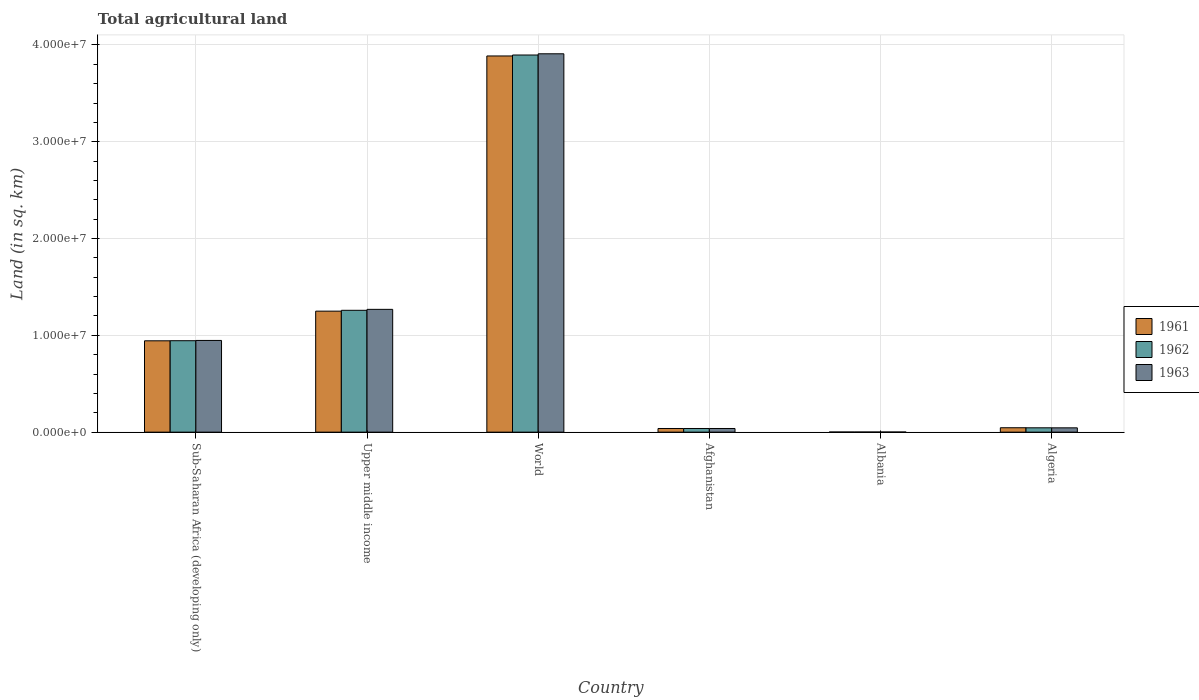How many different coloured bars are there?
Ensure brevity in your answer.  3. Are the number of bars per tick equal to the number of legend labels?
Ensure brevity in your answer.  Yes. How many bars are there on the 2nd tick from the left?
Provide a short and direct response. 3. What is the label of the 1st group of bars from the left?
Make the answer very short. Sub-Saharan Africa (developing only). In how many cases, is the number of bars for a given country not equal to the number of legend labels?
Your response must be concise. 0. What is the total agricultural land in 1961 in Sub-Saharan Africa (developing only)?
Offer a terse response. 9.44e+06. Across all countries, what is the maximum total agricultural land in 1962?
Give a very brief answer. 3.90e+07. Across all countries, what is the minimum total agricultural land in 1962?
Your answer should be very brief. 1.23e+04. In which country was the total agricultural land in 1961 minimum?
Give a very brief answer. Albania. What is the total total agricultural land in 1961 in the graph?
Keep it short and to the point. 6.16e+07. What is the difference between the total agricultural land in 1962 in Afghanistan and that in Sub-Saharan Africa (developing only)?
Keep it short and to the point. -9.07e+06. What is the difference between the total agricultural land in 1963 in World and the total agricultural land in 1962 in Afghanistan?
Offer a terse response. 3.87e+07. What is the average total agricultural land in 1962 per country?
Your response must be concise. 1.03e+07. What is the difference between the total agricultural land of/in 1961 and total agricultural land of/in 1963 in Algeria?
Make the answer very short. 9610. In how many countries, is the total agricultural land in 1962 greater than 6000000 sq.km?
Make the answer very short. 3. What is the ratio of the total agricultural land in 1961 in Sub-Saharan Africa (developing only) to that in World?
Make the answer very short. 0.24. Is the total agricultural land in 1963 in Afghanistan less than that in Algeria?
Provide a short and direct response. Yes. What is the difference between the highest and the second highest total agricultural land in 1963?
Your answer should be very brief. -2.64e+07. What is the difference between the highest and the lowest total agricultural land in 1963?
Ensure brevity in your answer.  3.91e+07. Is the sum of the total agricultural land in 1963 in Sub-Saharan Africa (developing only) and World greater than the maximum total agricultural land in 1961 across all countries?
Ensure brevity in your answer.  Yes. What does the 3rd bar from the left in World represents?
Offer a very short reply. 1963. What does the 2nd bar from the right in Algeria represents?
Your answer should be compact. 1962. Is it the case that in every country, the sum of the total agricultural land in 1961 and total agricultural land in 1962 is greater than the total agricultural land in 1963?
Make the answer very short. Yes. How many bars are there?
Your response must be concise. 18. Are all the bars in the graph horizontal?
Offer a terse response. No. What is the difference between two consecutive major ticks on the Y-axis?
Offer a very short reply. 1.00e+07. Does the graph contain grids?
Your answer should be compact. Yes. How many legend labels are there?
Make the answer very short. 3. How are the legend labels stacked?
Your response must be concise. Vertical. What is the title of the graph?
Provide a short and direct response. Total agricultural land. Does "1966" appear as one of the legend labels in the graph?
Give a very brief answer. No. What is the label or title of the Y-axis?
Provide a succinct answer. Land (in sq. km). What is the Land (in sq. km) of 1961 in Sub-Saharan Africa (developing only)?
Offer a terse response. 9.44e+06. What is the Land (in sq. km) of 1962 in Sub-Saharan Africa (developing only)?
Ensure brevity in your answer.  9.44e+06. What is the Land (in sq. km) in 1963 in Sub-Saharan Africa (developing only)?
Ensure brevity in your answer.  9.47e+06. What is the Land (in sq. km) of 1961 in Upper middle income?
Offer a terse response. 1.25e+07. What is the Land (in sq. km) in 1962 in Upper middle income?
Your response must be concise. 1.26e+07. What is the Land (in sq. km) in 1963 in Upper middle income?
Your answer should be compact. 1.27e+07. What is the Land (in sq. km) in 1961 in World?
Keep it short and to the point. 3.89e+07. What is the Land (in sq. km) of 1962 in World?
Your answer should be very brief. 3.90e+07. What is the Land (in sq. km) of 1963 in World?
Your response must be concise. 3.91e+07. What is the Land (in sq. km) of 1961 in Afghanistan?
Make the answer very short. 3.77e+05. What is the Land (in sq. km) of 1962 in Afghanistan?
Offer a terse response. 3.78e+05. What is the Land (in sq. km) in 1963 in Afghanistan?
Your answer should be very brief. 3.78e+05. What is the Land (in sq. km) in 1961 in Albania?
Your response must be concise. 1.23e+04. What is the Land (in sq. km) in 1962 in Albania?
Keep it short and to the point. 1.23e+04. What is the Land (in sq. km) of 1963 in Albania?
Provide a short and direct response. 1.23e+04. What is the Land (in sq. km) of 1961 in Algeria?
Offer a terse response. 4.55e+05. What is the Land (in sq. km) in 1962 in Algeria?
Make the answer very short. 4.49e+05. What is the Land (in sq. km) of 1963 in Algeria?
Give a very brief answer. 4.45e+05. Across all countries, what is the maximum Land (in sq. km) of 1961?
Give a very brief answer. 3.89e+07. Across all countries, what is the maximum Land (in sq. km) in 1962?
Make the answer very short. 3.90e+07. Across all countries, what is the maximum Land (in sq. km) in 1963?
Your response must be concise. 3.91e+07. Across all countries, what is the minimum Land (in sq. km) of 1961?
Your response must be concise. 1.23e+04. Across all countries, what is the minimum Land (in sq. km) of 1962?
Your response must be concise. 1.23e+04. Across all countries, what is the minimum Land (in sq. km) of 1963?
Give a very brief answer. 1.23e+04. What is the total Land (in sq. km) of 1961 in the graph?
Your answer should be very brief. 6.16e+07. What is the total Land (in sq. km) of 1962 in the graph?
Provide a succinct answer. 6.18e+07. What is the total Land (in sq. km) of 1963 in the graph?
Keep it short and to the point. 6.21e+07. What is the difference between the Land (in sq. km) in 1961 in Sub-Saharan Africa (developing only) and that in Upper middle income?
Your response must be concise. -3.06e+06. What is the difference between the Land (in sq. km) of 1962 in Sub-Saharan Africa (developing only) and that in Upper middle income?
Your answer should be very brief. -3.14e+06. What is the difference between the Land (in sq. km) of 1963 in Sub-Saharan Africa (developing only) and that in Upper middle income?
Give a very brief answer. -3.21e+06. What is the difference between the Land (in sq. km) of 1961 in Sub-Saharan Africa (developing only) and that in World?
Ensure brevity in your answer.  -2.94e+07. What is the difference between the Land (in sq. km) of 1962 in Sub-Saharan Africa (developing only) and that in World?
Provide a succinct answer. -2.95e+07. What is the difference between the Land (in sq. km) in 1963 in Sub-Saharan Africa (developing only) and that in World?
Give a very brief answer. -2.96e+07. What is the difference between the Land (in sq. km) in 1961 in Sub-Saharan Africa (developing only) and that in Afghanistan?
Ensure brevity in your answer.  9.06e+06. What is the difference between the Land (in sq. km) of 1962 in Sub-Saharan Africa (developing only) and that in Afghanistan?
Provide a succinct answer. 9.07e+06. What is the difference between the Land (in sq. km) of 1963 in Sub-Saharan Africa (developing only) and that in Afghanistan?
Give a very brief answer. 9.10e+06. What is the difference between the Land (in sq. km) in 1961 in Sub-Saharan Africa (developing only) and that in Albania?
Give a very brief answer. 9.42e+06. What is the difference between the Land (in sq. km) of 1962 in Sub-Saharan Africa (developing only) and that in Albania?
Provide a succinct answer. 9.43e+06. What is the difference between the Land (in sq. km) of 1963 in Sub-Saharan Africa (developing only) and that in Albania?
Keep it short and to the point. 9.46e+06. What is the difference between the Land (in sq. km) of 1961 in Sub-Saharan Africa (developing only) and that in Algeria?
Offer a very short reply. 8.98e+06. What is the difference between the Land (in sq. km) in 1962 in Sub-Saharan Africa (developing only) and that in Algeria?
Your answer should be very brief. 9.00e+06. What is the difference between the Land (in sq. km) of 1963 in Sub-Saharan Africa (developing only) and that in Algeria?
Ensure brevity in your answer.  9.03e+06. What is the difference between the Land (in sq. km) of 1961 in Upper middle income and that in World?
Your answer should be very brief. -2.64e+07. What is the difference between the Land (in sq. km) in 1962 in Upper middle income and that in World?
Your answer should be very brief. -2.64e+07. What is the difference between the Land (in sq. km) in 1963 in Upper middle income and that in World?
Offer a very short reply. -2.64e+07. What is the difference between the Land (in sq. km) of 1961 in Upper middle income and that in Afghanistan?
Offer a very short reply. 1.21e+07. What is the difference between the Land (in sq. km) of 1962 in Upper middle income and that in Afghanistan?
Offer a very short reply. 1.22e+07. What is the difference between the Land (in sq. km) of 1963 in Upper middle income and that in Afghanistan?
Keep it short and to the point. 1.23e+07. What is the difference between the Land (in sq. km) of 1961 in Upper middle income and that in Albania?
Provide a short and direct response. 1.25e+07. What is the difference between the Land (in sq. km) in 1962 in Upper middle income and that in Albania?
Give a very brief answer. 1.26e+07. What is the difference between the Land (in sq. km) of 1963 in Upper middle income and that in Albania?
Keep it short and to the point. 1.27e+07. What is the difference between the Land (in sq. km) in 1961 in Upper middle income and that in Algeria?
Offer a terse response. 1.20e+07. What is the difference between the Land (in sq. km) in 1962 in Upper middle income and that in Algeria?
Ensure brevity in your answer.  1.21e+07. What is the difference between the Land (in sq. km) in 1963 in Upper middle income and that in Algeria?
Ensure brevity in your answer.  1.22e+07. What is the difference between the Land (in sq. km) in 1961 in World and that in Afghanistan?
Offer a terse response. 3.85e+07. What is the difference between the Land (in sq. km) in 1962 in World and that in Afghanistan?
Keep it short and to the point. 3.86e+07. What is the difference between the Land (in sq. km) in 1963 in World and that in Afghanistan?
Make the answer very short. 3.87e+07. What is the difference between the Land (in sq. km) of 1961 in World and that in Albania?
Your answer should be very brief. 3.88e+07. What is the difference between the Land (in sq. km) in 1962 in World and that in Albania?
Your answer should be compact. 3.89e+07. What is the difference between the Land (in sq. km) of 1963 in World and that in Albania?
Provide a succinct answer. 3.91e+07. What is the difference between the Land (in sq. km) in 1961 in World and that in Algeria?
Your answer should be very brief. 3.84e+07. What is the difference between the Land (in sq. km) of 1962 in World and that in Algeria?
Your response must be concise. 3.85e+07. What is the difference between the Land (in sq. km) of 1963 in World and that in Algeria?
Make the answer very short. 3.86e+07. What is the difference between the Land (in sq. km) of 1961 in Afghanistan and that in Albania?
Your answer should be very brief. 3.65e+05. What is the difference between the Land (in sq. km) of 1962 in Afghanistan and that in Albania?
Keep it short and to the point. 3.65e+05. What is the difference between the Land (in sq. km) of 1963 in Afghanistan and that in Albania?
Make the answer very short. 3.66e+05. What is the difference between the Land (in sq. km) of 1961 in Afghanistan and that in Algeria?
Give a very brief answer. -7.77e+04. What is the difference between the Land (in sq. km) of 1962 in Afghanistan and that in Algeria?
Your answer should be compact. -7.14e+04. What is the difference between the Land (in sq. km) of 1963 in Afghanistan and that in Algeria?
Your answer should be compact. -6.70e+04. What is the difference between the Land (in sq. km) of 1961 in Albania and that in Algeria?
Offer a very short reply. -4.42e+05. What is the difference between the Land (in sq. km) of 1962 in Albania and that in Algeria?
Provide a succinct answer. -4.37e+05. What is the difference between the Land (in sq. km) of 1963 in Albania and that in Algeria?
Provide a short and direct response. -4.33e+05. What is the difference between the Land (in sq. km) in 1961 in Sub-Saharan Africa (developing only) and the Land (in sq. km) in 1962 in Upper middle income?
Give a very brief answer. -3.15e+06. What is the difference between the Land (in sq. km) of 1961 in Sub-Saharan Africa (developing only) and the Land (in sq. km) of 1963 in Upper middle income?
Offer a terse response. -3.25e+06. What is the difference between the Land (in sq. km) of 1962 in Sub-Saharan Africa (developing only) and the Land (in sq. km) of 1963 in Upper middle income?
Your answer should be compact. -3.24e+06. What is the difference between the Land (in sq. km) in 1961 in Sub-Saharan Africa (developing only) and the Land (in sq. km) in 1962 in World?
Your answer should be compact. -2.95e+07. What is the difference between the Land (in sq. km) in 1961 in Sub-Saharan Africa (developing only) and the Land (in sq. km) in 1963 in World?
Ensure brevity in your answer.  -2.96e+07. What is the difference between the Land (in sq. km) of 1962 in Sub-Saharan Africa (developing only) and the Land (in sq. km) of 1963 in World?
Offer a terse response. -2.96e+07. What is the difference between the Land (in sq. km) of 1961 in Sub-Saharan Africa (developing only) and the Land (in sq. km) of 1962 in Afghanistan?
Give a very brief answer. 9.06e+06. What is the difference between the Land (in sq. km) of 1961 in Sub-Saharan Africa (developing only) and the Land (in sq. km) of 1963 in Afghanistan?
Your answer should be very brief. 9.06e+06. What is the difference between the Land (in sq. km) of 1962 in Sub-Saharan Africa (developing only) and the Land (in sq. km) of 1963 in Afghanistan?
Your response must be concise. 9.07e+06. What is the difference between the Land (in sq. km) of 1961 in Sub-Saharan Africa (developing only) and the Land (in sq. km) of 1962 in Albania?
Offer a terse response. 9.42e+06. What is the difference between the Land (in sq. km) of 1961 in Sub-Saharan Africa (developing only) and the Land (in sq. km) of 1963 in Albania?
Provide a short and direct response. 9.42e+06. What is the difference between the Land (in sq. km) of 1962 in Sub-Saharan Africa (developing only) and the Land (in sq. km) of 1963 in Albania?
Offer a terse response. 9.43e+06. What is the difference between the Land (in sq. km) in 1961 in Sub-Saharan Africa (developing only) and the Land (in sq. km) in 1962 in Algeria?
Provide a short and direct response. 8.99e+06. What is the difference between the Land (in sq. km) in 1961 in Sub-Saharan Africa (developing only) and the Land (in sq. km) in 1963 in Algeria?
Offer a terse response. 8.99e+06. What is the difference between the Land (in sq. km) in 1962 in Sub-Saharan Africa (developing only) and the Land (in sq. km) in 1963 in Algeria?
Provide a succinct answer. 9.00e+06. What is the difference between the Land (in sq. km) of 1961 in Upper middle income and the Land (in sq. km) of 1962 in World?
Offer a very short reply. -2.65e+07. What is the difference between the Land (in sq. km) of 1961 in Upper middle income and the Land (in sq. km) of 1963 in World?
Your answer should be compact. -2.66e+07. What is the difference between the Land (in sq. km) of 1962 in Upper middle income and the Land (in sq. km) of 1963 in World?
Offer a very short reply. -2.65e+07. What is the difference between the Land (in sq. km) of 1961 in Upper middle income and the Land (in sq. km) of 1962 in Afghanistan?
Your response must be concise. 1.21e+07. What is the difference between the Land (in sq. km) of 1961 in Upper middle income and the Land (in sq. km) of 1963 in Afghanistan?
Ensure brevity in your answer.  1.21e+07. What is the difference between the Land (in sq. km) of 1962 in Upper middle income and the Land (in sq. km) of 1963 in Afghanistan?
Ensure brevity in your answer.  1.22e+07. What is the difference between the Land (in sq. km) in 1961 in Upper middle income and the Land (in sq. km) in 1962 in Albania?
Your answer should be very brief. 1.25e+07. What is the difference between the Land (in sq. km) in 1961 in Upper middle income and the Land (in sq. km) in 1963 in Albania?
Your answer should be compact. 1.25e+07. What is the difference between the Land (in sq. km) of 1962 in Upper middle income and the Land (in sq. km) of 1963 in Albania?
Keep it short and to the point. 1.26e+07. What is the difference between the Land (in sq. km) of 1961 in Upper middle income and the Land (in sq. km) of 1962 in Algeria?
Make the answer very short. 1.21e+07. What is the difference between the Land (in sq. km) in 1961 in Upper middle income and the Land (in sq. km) in 1963 in Algeria?
Your answer should be very brief. 1.21e+07. What is the difference between the Land (in sq. km) of 1962 in Upper middle income and the Land (in sq. km) of 1963 in Algeria?
Your answer should be very brief. 1.21e+07. What is the difference between the Land (in sq. km) in 1961 in World and the Land (in sq. km) in 1962 in Afghanistan?
Give a very brief answer. 3.85e+07. What is the difference between the Land (in sq. km) of 1961 in World and the Land (in sq. km) of 1963 in Afghanistan?
Ensure brevity in your answer.  3.85e+07. What is the difference between the Land (in sq. km) of 1962 in World and the Land (in sq. km) of 1963 in Afghanistan?
Provide a short and direct response. 3.86e+07. What is the difference between the Land (in sq. km) in 1961 in World and the Land (in sq. km) in 1962 in Albania?
Give a very brief answer. 3.88e+07. What is the difference between the Land (in sq. km) of 1961 in World and the Land (in sq. km) of 1963 in Albania?
Provide a short and direct response. 3.88e+07. What is the difference between the Land (in sq. km) in 1962 in World and the Land (in sq. km) in 1963 in Albania?
Keep it short and to the point. 3.89e+07. What is the difference between the Land (in sq. km) of 1961 in World and the Land (in sq. km) of 1962 in Algeria?
Provide a succinct answer. 3.84e+07. What is the difference between the Land (in sq. km) in 1961 in World and the Land (in sq. km) in 1963 in Algeria?
Give a very brief answer. 3.84e+07. What is the difference between the Land (in sq. km) in 1962 in World and the Land (in sq. km) in 1963 in Algeria?
Make the answer very short. 3.85e+07. What is the difference between the Land (in sq. km) in 1961 in Afghanistan and the Land (in sq. km) in 1962 in Albania?
Your response must be concise. 3.65e+05. What is the difference between the Land (in sq. km) of 1961 in Afghanistan and the Land (in sq. km) of 1963 in Albania?
Your answer should be compact. 3.65e+05. What is the difference between the Land (in sq. km) of 1962 in Afghanistan and the Land (in sq. km) of 1963 in Albania?
Ensure brevity in your answer.  3.65e+05. What is the difference between the Land (in sq. km) in 1961 in Afghanistan and the Land (in sq. km) in 1962 in Algeria?
Your answer should be compact. -7.20e+04. What is the difference between the Land (in sq. km) of 1961 in Afghanistan and the Land (in sq. km) of 1963 in Algeria?
Your response must be concise. -6.81e+04. What is the difference between the Land (in sq. km) of 1962 in Afghanistan and the Land (in sq. km) of 1963 in Algeria?
Offer a very short reply. -6.75e+04. What is the difference between the Land (in sq. km) of 1961 in Albania and the Land (in sq. km) of 1962 in Algeria?
Your answer should be compact. -4.37e+05. What is the difference between the Land (in sq. km) in 1961 in Albania and the Land (in sq. km) in 1963 in Algeria?
Ensure brevity in your answer.  -4.33e+05. What is the difference between the Land (in sq. km) in 1962 in Albania and the Land (in sq. km) in 1963 in Algeria?
Provide a succinct answer. -4.33e+05. What is the average Land (in sq. km) in 1961 per country?
Offer a very short reply. 1.03e+07. What is the average Land (in sq. km) in 1962 per country?
Provide a short and direct response. 1.03e+07. What is the average Land (in sq. km) in 1963 per country?
Keep it short and to the point. 1.03e+07. What is the difference between the Land (in sq. km) of 1961 and Land (in sq. km) of 1962 in Sub-Saharan Africa (developing only)?
Your answer should be very brief. -8204.9. What is the difference between the Land (in sq. km) of 1961 and Land (in sq. km) of 1963 in Sub-Saharan Africa (developing only)?
Offer a very short reply. -3.66e+04. What is the difference between the Land (in sq. km) in 1962 and Land (in sq. km) in 1963 in Sub-Saharan Africa (developing only)?
Keep it short and to the point. -2.84e+04. What is the difference between the Land (in sq. km) of 1961 and Land (in sq. km) of 1962 in Upper middle income?
Keep it short and to the point. -8.73e+04. What is the difference between the Land (in sq. km) of 1961 and Land (in sq. km) of 1963 in Upper middle income?
Your answer should be compact. -1.85e+05. What is the difference between the Land (in sq. km) of 1962 and Land (in sq. km) of 1963 in Upper middle income?
Provide a succinct answer. -9.80e+04. What is the difference between the Land (in sq. km) in 1961 and Land (in sq. km) in 1962 in World?
Your response must be concise. -9.81e+04. What is the difference between the Land (in sq. km) of 1961 and Land (in sq. km) of 1963 in World?
Give a very brief answer. -2.23e+05. What is the difference between the Land (in sq. km) of 1962 and Land (in sq. km) of 1963 in World?
Give a very brief answer. -1.25e+05. What is the difference between the Land (in sq. km) in 1961 and Land (in sq. km) in 1962 in Afghanistan?
Provide a succinct answer. -600. What is the difference between the Land (in sq. km) in 1961 and Land (in sq. km) in 1963 in Afghanistan?
Your answer should be very brief. -1100. What is the difference between the Land (in sq. km) in 1962 and Land (in sq. km) in 1963 in Afghanistan?
Provide a short and direct response. -500. What is the difference between the Land (in sq. km) in 1961 and Land (in sq. km) in 1962 in Albania?
Make the answer very short. 0. What is the difference between the Land (in sq. km) of 1961 and Land (in sq. km) of 1962 in Algeria?
Your response must be concise. 5710. What is the difference between the Land (in sq. km) in 1961 and Land (in sq. km) in 1963 in Algeria?
Your answer should be very brief. 9610. What is the difference between the Land (in sq. km) of 1962 and Land (in sq. km) of 1963 in Algeria?
Your answer should be compact. 3900. What is the ratio of the Land (in sq. km) in 1961 in Sub-Saharan Africa (developing only) to that in Upper middle income?
Provide a succinct answer. 0.76. What is the ratio of the Land (in sq. km) of 1962 in Sub-Saharan Africa (developing only) to that in Upper middle income?
Your answer should be very brief. 0.75. What is the ratio of the Land (in sq. km) of 1963 in Sub-Saharan Africa (developing only) to that in Upper middle income?
Offer a terse response. 0.75. What is the ratio of the Land (in sq. km) of 1961 in Sub-Saharan Africa (developing only) to that in World?
Your answer should be compact. 0.24. What is the ratio of the Land (in sq. km) in 1962 in Sub-Saharan Africa (developing only) to that in World?
Your answer should be very brief. 0.24. What is the ratio of the Land (in sq. km) of 1963 in Sub-Saharan Africa (developing only) to that in World?
Your answer should be very brief. 0.24. What is the ratio of the Land (in sq. km) in 1961 in Sub-Saharan Africa (developing only) to that in Afghanistan?
Give a very brief answer. 25.03. What is the ratio of the Land (in sq. km) of 1962 in Sub-Saharan Africa (developing only) to that in Afghanistan?
Keep it short and to the point. 25.01. What is the ratio of the Land (in sq. km) in 1963 in Sub-Saharan Africa (developing only) to that in Afghanistan?
Make the answer very short. 25.05. What is the ratio of the Land (in sq. km) of 1961 in Sub-Saharan Africa (developing only) to that in Albania?
Your response must be concise. 765.97. What is the ratio of the Land (in sq. km) in 1962 in Sub-Saharan Africa (developing only) to that in Albania?
Keep it short and to the point. 766.63. What is the ratio of the Land (in sq. km) of 1963 in Sub-Saharan Africa (developing only) to that in Albania?
Ensure brevity in your answer.  768.31. What is the ratio of the Land (in sq. km) in 1961 in Sub-Saharan Africa (developing only) to that in Algeria?
Keep it short and to the point. 20.75. What is the ratio of the Land (in sq. km) of 1962 in Sub-Saharan Africa (developing only) to that in Algeria?
Your answer should be compact. 21.04. What is the ratio of the Land (in sq. km) in 1963 in Sub-Saharan Africa (developing only) to that in Algeria?
Ensure brevity in your answer.  21.28. What is the ratio of the Land (in sq. km) of 1961 in Upper middle income to that in World?
Ensure brevity in your answer.  0.32. What is the ratio of the Land (in sq. km) of 1962 in Upper middle income to that in World?
Provide a short and direct response. 0.32. What is the ratio of the Land (in sq. km) of 1963 in Upper middle income to that in World?
Keep it short and to the point. 0.32. What is the ratio of the Land (in sq. km) in 1961 in Upper middle income to that in Afghanistan?
Ensure brevity in your answer.  33.15. What is the ratio of the Land (in sq. km) in 1962 in Upper middle income to that in Afghanistan?
Ensure brevity in your answer.  33.33. What is the ratio of the Land (in sq. km) of 1963 in Upper middle income to that in Afghanistan?
Provide a short and direct response. 33.55. What is the ratio of the Land (in sq. km) in 1961 in Upper middle income to that in Albania?
Your response must be concise. 1014.54. What is the ratio of the Land (in sq. km) of 1962 in Upper middle income to that in Albania?
Provide a succinct answer. 1021.62. What is the ratio of the Land (in sq. km) in 1963 in Upper middle income to that in Albania?
Your answer should be very brief. 1028.75. What is the ratio of the Land (in sq. km) of 1961 in Upper middle income to that in Algeria?
Your response must be concise. 27.49. What is the ratio of the Land (in sq. km) of 1962 in Upper middle income to that in Algeria?
Your response must be concise. 28.03. What is the ratio of the Land (in sq. km) of 1963 in Upper middle income to that in Algeria?
Offer a terse response. 28.5. What is the ratio of the Land (in sq. km) in 1961 in World to that in Afghanistan?
Keep it short and to the point. 103.08. What is the ratio of the Land (in sq. km) of 1962 in World to that in Afghanistan?
Give a very brief answer. 103.18. What is the ratio of the Land (in sq. km) in 1963 in World to that in Afghanistan?
Offer a terse response. 103.37. What is the ratio of the Land (in sq. km) of 1961 in World to that in Albania?
Offer a terse response. 3154.35. What is the ratio of the Land (in sq. km) of 1962 in World to that in Albania?
Make the answer very short. 3162.31. What is the ratio of the Land (in sq. km) of 1963 in World to that in Albania?
Provide a short and direct response. 3169.91. What is the ratio of the Land (in sq. km) in 1961 in World to that in Algeria?
Offer a very short reply. 85.46. What is the ratio of the Land (in sq. km) of 1962 in World to that in Algeria?
Make the answer very short. 86.77. What is the ratio of the Land (in sq. km) in 1963 in World to that in Algeria?
Give a very brief answer. 87.81. What is the ratio of the Land (in sq. km) of 1961 in Afghanistan to that in Albania?
Your response must be concise. 30.6. What is the ratio of the Land (in sq. km) in 1962 in Afghanistan to that in Albania?
Ensure brevity in your answer.  30.65. What is the ratio of the Land (in sq. km) in 1963 in Afghanistan to that in Albania?
Make the answer very short. 30.66. What is the ratio of the Land (in sq. km) in 1961 in Afghanistan to that in Algeria?
Your answer should be compact. 0.83. What is the ratio of the Land (in sq. km) of 1962 in Afghanistan to that in Algeria?
Keep it short and to the point. 0.84. What is the ratio of the Land (in sq. km) of 1963 in Afghanistan to that in Algeria?
Your response must be concise. 0.85. What is the ratio of the Land (in sq. km) of 1961 in Albania to that in Algeria?
Your answer should be compact. 0.03. What is the ratio of the Land (in sq. km) in 1962 in Albania to that in Algeria?
Offer a terse response. 0.03. What is the ratio of the Land (in sq. km) in 1963 in Albania to that in Algeria?
Keep it short and to the point. 0.03. What is the difference between the highest and the second highest Land (in sq. km) of 1961?
Make the answer very short. 2.64e+07. What is the difference between the highest and the second highest Land (in sq. km) of 1962?
Make the answer very short. 2.64e+07. What is the difference between the highest and the second highest Land (in sq. km) in 1963?
Your answer should be very brief. 2.64e+07. What is the difference between the highest and the lowest Land (in sq. km) in 1961?
Offer a very short reply. 3.88e+07. What is the difference between the highest and the lowest Land (in sq. km) of 1962?
Your answer should be very brief. 3.89e+07. What is the difference between the highest and the lowest Land (in sq. km) of 1963?
Make the answer very short. 3.91e+07. 